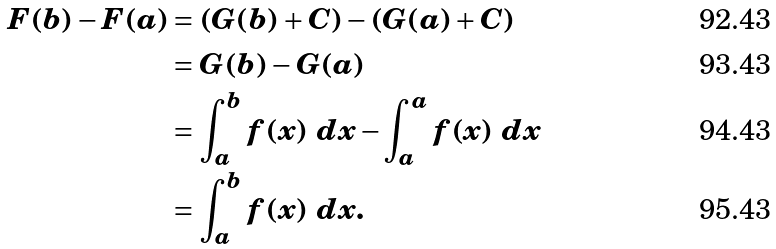<formula> <loc_0><loc_0><loc_500><loc_500>F ( b ) - F ( a ) & = ( G ( b ) + C ) - ( G ( a ) + C ) \\ & = G ( b ) - G ( a ) \\ & = \int _ { a } ^ { b } f ( x ) \ d x - \int _ { a } ^ { a } f ( x ) \ d x \\ & = \int _ { a } ^ { b } f ( x ) \ d x .</formula> 